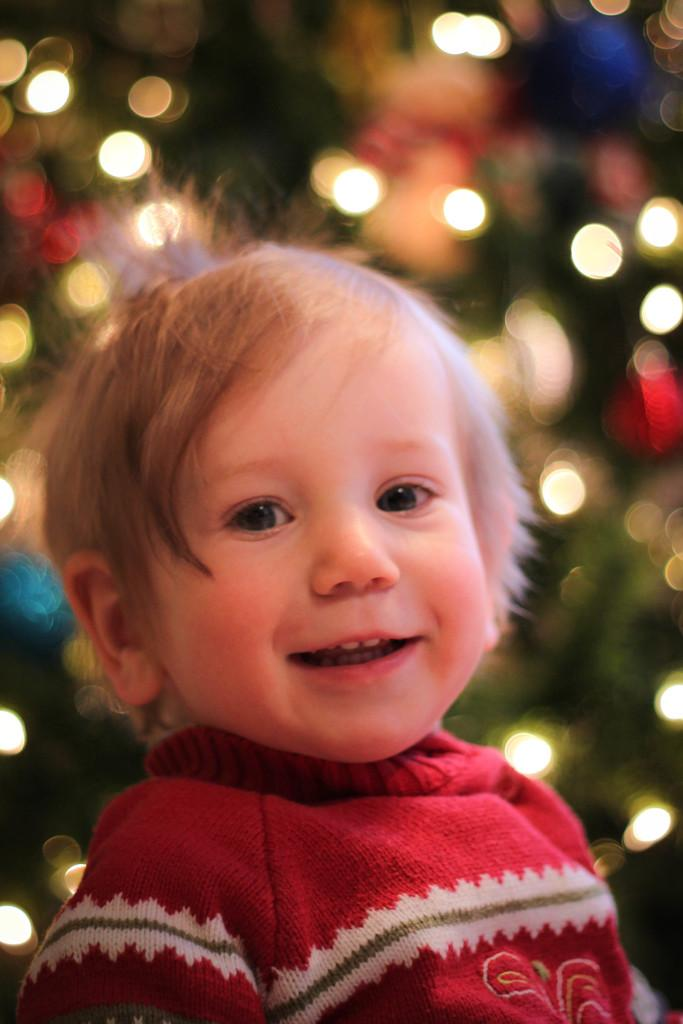What is the main subject of the image? The main subject of the image is a kid's face. What is the kid wearing in the image? The kid is wearing a red dress in the image. Can you describe the background of the image? The background of the image is blurred. What type of jewel can be seen on the kid's forehead in the image? There is no jewel present on the kid's forehead in the image. How does the kid express regret in the image? There is no indication of regret in the image, as it only shows the kid's face and the fact that they are wearing a red dress. 